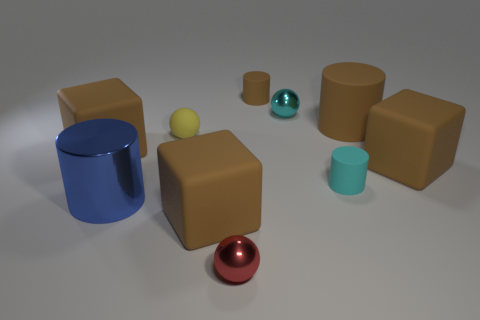How many brown cubes must be subtracted to get 1 brown cubes? 2 Subtract all tiny matte spheres. How many spheres are left? 2 Subtract all red balls. How many balls are left? 2 Subtract 1 balls. How many balls are left? 2 Subtract all purple blocks. How many brown cylinders are left? 2 Subtract all balls. How many objects are left? 7 Subtract all red blocks. Subtract all brown cylinders. How many blocks are left? 3 Subtract all tiny brown matte cylinders. Subtract all matte blocks. How many objects are left? 6 Add 7 small cyan matte objects. How many small cyan matte objects are left? 8 Add 6 red matte balls. How many red matte balls exist? 6 